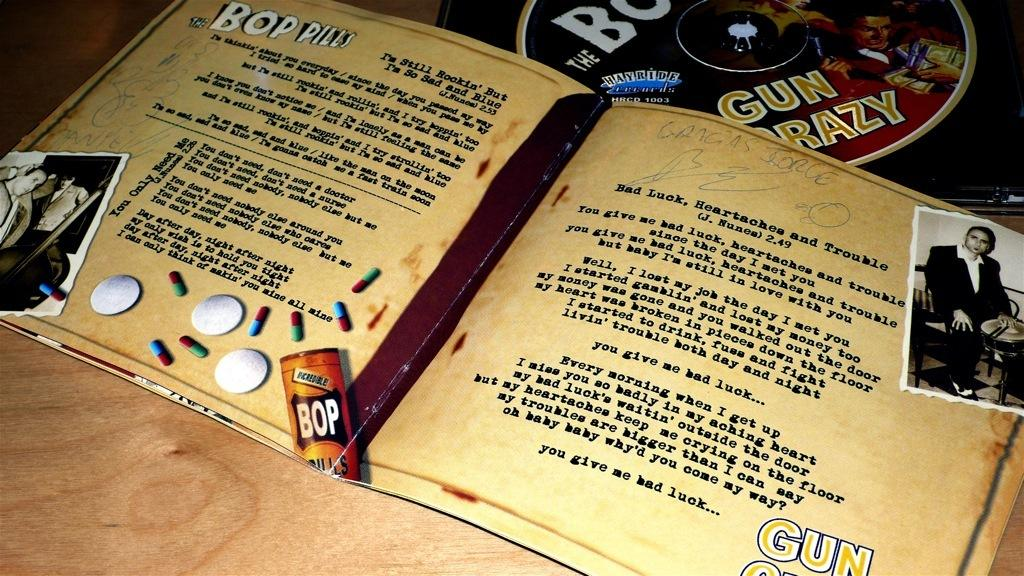<image>
Give a short and clear explanation of the subsequent image. A CD from the Bop Pills has the liner notes opened to show some lyrics. 